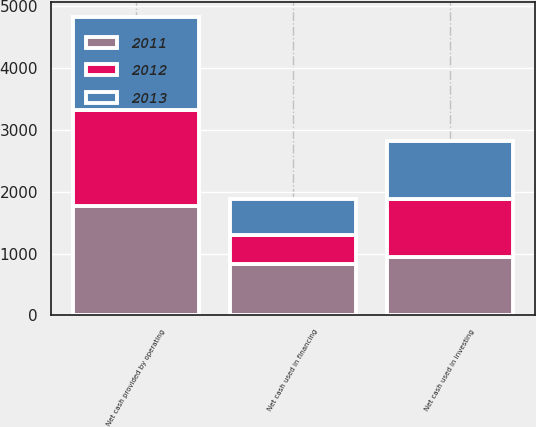Convert chart to OTSL. <chart><loc_0><loc_0><loc_500><loc_500><stacked_bar_chart><ecel><fcel>Net cash provided by operating<fcel>Net cash used in investing<fcel>Net cash used in financing<nl><fcel>2012<fcel>1548.2<fcel>933.8<fcel>468.7<nl><fcel>2013<fcel>1513.8<fcel>937.6<fcel>574.9<nl><fcel>2011<fcel>1766.7<fcel>950.2<fcel>838.5<nl></chart> 